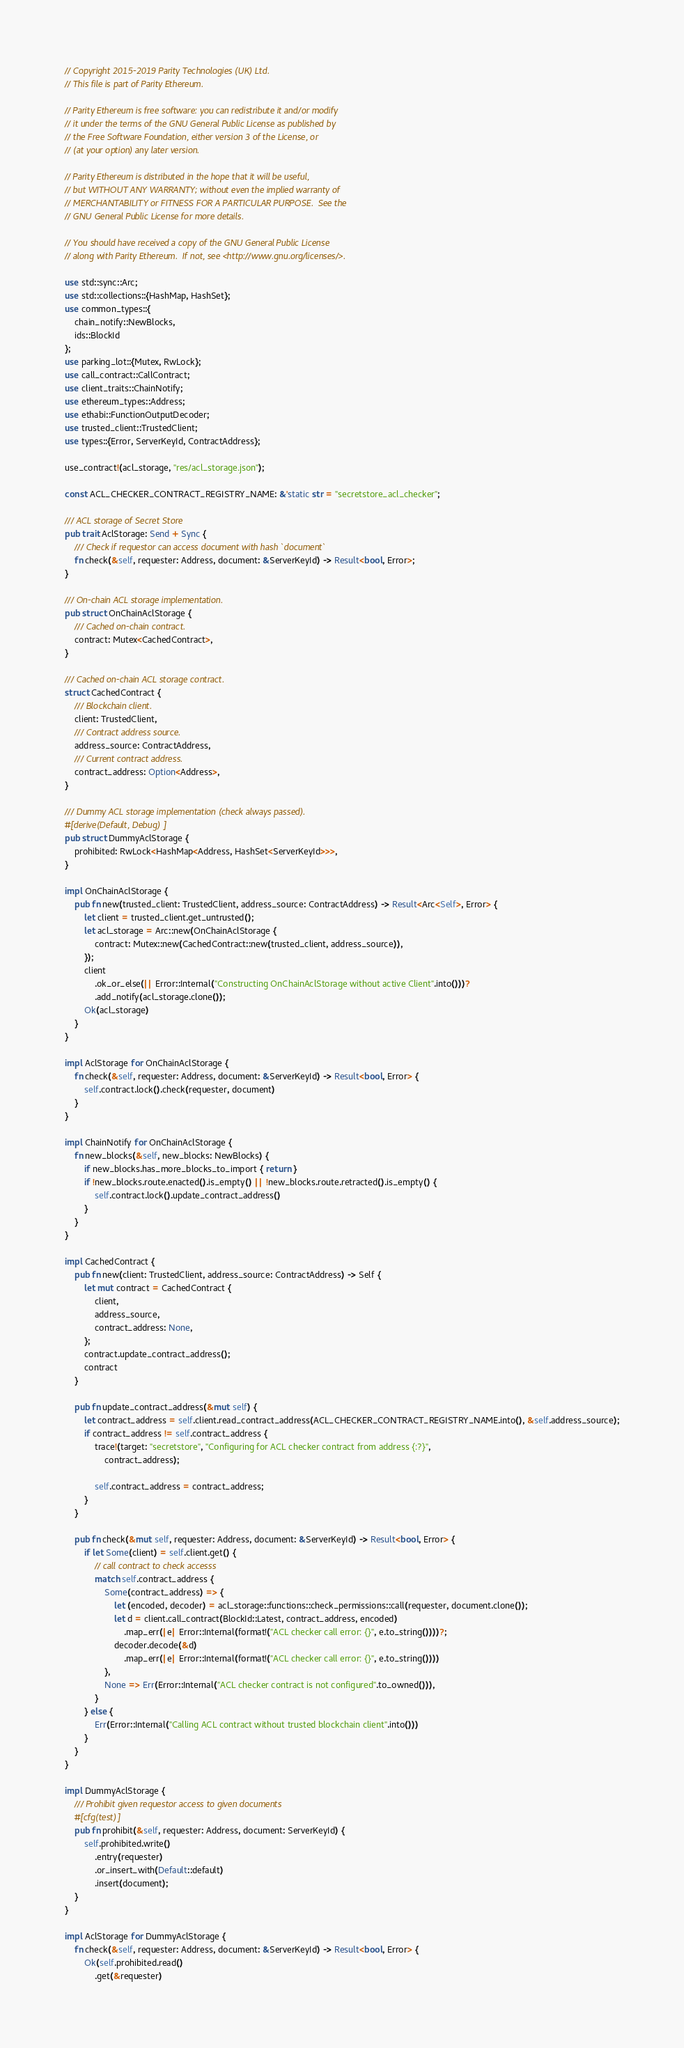Convert code to text. <code><loc_0><loc_0><loc_500><loc_500><_Rust_>// Copyright 2015-2019 Parity Technologies (UK) Ltd.
// This file is part of Parity Ethereum.

// Parity Ethereum is free software: you can redistribute it and/or modify
// it under the terms of the GNU General Public License as published by
// the Free Software Foundation, either version 3 of the License, or
// (at your option) any later version.

// Parity Ethereum is distributed in the hope that it will be useful,
// but WITHOUT ANY WARRANTY; without even the implied warranty of
// MERCHANTABILITY or FITNESS FOR A PARTICULAR PURPOSE.  See the
// GNU General Public License for more details.

// You should have received a copy of the GNU General Public License
// along with Parity Ethereum.  If not, see <http://www.gnu.org/licenses/>.

use std::sync::Arc;
use std::collections::{HashMap, HashSet};
use common_types::{
	chain_notify::NewBlocks,
	ids::BlockId
};
use parking_lot::{Mutex, RwLock};
use call_contract::CallContract;
use client_traits::ChainNotify;
use ethereum_types::Address;
use ethabi::FunctionOutputDecoder;
use trusted_client::TrustedClient;
use types::{Error, ServerKeyId, ContractAddress};

use_contract!(acl_storage, "res/acl_storage.json");

const ACL_CHECKER_CONTRACT_REGISTRY_NAME: &'static str = "secretstore_acl_checker";

/// ACL storage of Secret Store
pub trait AclStorage: Send + Sync {
	/// Check if requestor can access document with hash `document`
	fn check(&self, requester: Address, document: &ServerKeyId) -> Result<bool, Error>;
}

/// On-chain ACL storage implementation.
pub struct OnChainAclStorage {
	/// Cached on-chain contract.
	contract: Mutex<CachedContract>,
}

/// Cached on-chain ACL storage contract.
struct CachedContract {
	/// Blockchain client.
	client: TrustedClient,
	/// Contract address source.
	address_source: ContractAddress,
	/// Current contract address.
	contract_address: Option<Address>,
}

/// Dummy ACL storage implementation (check always passed).
#[derive(Default, Debug)]
pub struct DummyAclStorage {
	prohibited: RwLock<HashMap<Address, HashSet<ServerKeyId>>>,
}

impl OnChainAclStorage {
	pub fn new(trusted_client: TrustedClient, address_source: ContractAddress) -> Result<Arc<Self>, Error> {
		let client = trusted_client.get_untrusted();
		let acl_storage = Arc::new(OnChainAclStorage {
			contract: Mutex::new(CachedContract::new(trusted_client, address_source)),
		});
		client
			.ok_or_else(|| Error::Internal("Constructing OnChainAclStorage without active Client".into()))?
			.add_notify(acl_storage.clone());
		Ok(acl_storage)
	}
}

impl AclStorage for OnChainAclStorage {
	fn check(&self, requester: Address, document: &ServerKeyId) -> Result<bool, Error> {
		self.contract.lock().check(requester, document)
	}
}

impl ChainNotify for OnChainAclStorage {
	fn new_blocks(&self, new_blocks: NewBlocks) {
		if new_blocks.has_more_blocks_to_import { return }
		if !new_blocks.route.enacted().is_empty() || !new_blocks.route.retracted().is_empty() {
			self.contract.lock().update_contract_address()
		}
	}
}

impl CachedContract {
	pub fn new(client: TrustedClient, address_source: ContractAddress) -> Self {
		let mut contract = CachedContract {
			client,
			address_source,
			contract_address: None,
		};
		contract.update_contract_address();
		contract
	}

	pub fn update_contract_address(&mut self) {
		let contract_address = self.client.read_contract_address(ACL_CHECKER_CONTRACT_REGISTRY_NAME.into(), &self.address_source);
		if contract_address != self.contract_address {
			trace!(target: "secretstore", "Configuring for ACL checker contract from address {:?}",
				contract_address);

			self.contract_address = contract_address;
		}
	}

	pub fn check(&mut self, requester: Address, document: &ServerKeyId) -> Result<bool, Error> {
		if let Some(client) = self.client.get() {
			// call contract to check accesss
			match self.contract_address {
				Some(contract_address) => {
					let (encoded, decoder) = acl_storage::functions::check_permissions::call(requester, document.clone());
					let d = client.call_contract(BlockId::Latest, contract_address, encoded)
						.map_err(|e| Error::Internal(format!("ACL checker call error: {}", e.to_string())))?;
					decoder.decode(&d)
						.map_err(|e| Error::Internal(format!("ACL checker call error: {}", e.to_string())))
				},
				None => Err(Error::Internal("ACL checker contract is not configured".to_owned())),
			}
		} else {
			Err(Error::Internal("Calling ACL contract without trusted blockchain client".into()))
		}
	}
}

impl DummyAclStorage {
	/// Prohibit given requestor access to given documents
	#[cfg(test)]
	pub fn prohibit(&self, requester: Address, document: ServerKeyId) {
		self.prohibited.write()
			.entry(requester)
			.or_insert_with(Default::default)
			.insert(document);
	}
}

impl AclStorage for DummyAclStorage {
	fn check(&self, requester: Address, document: &ServerKeyId) -> Result<bool, Error> {
		Ok(self.prohibited.read()
			.get(&requester)</code> 